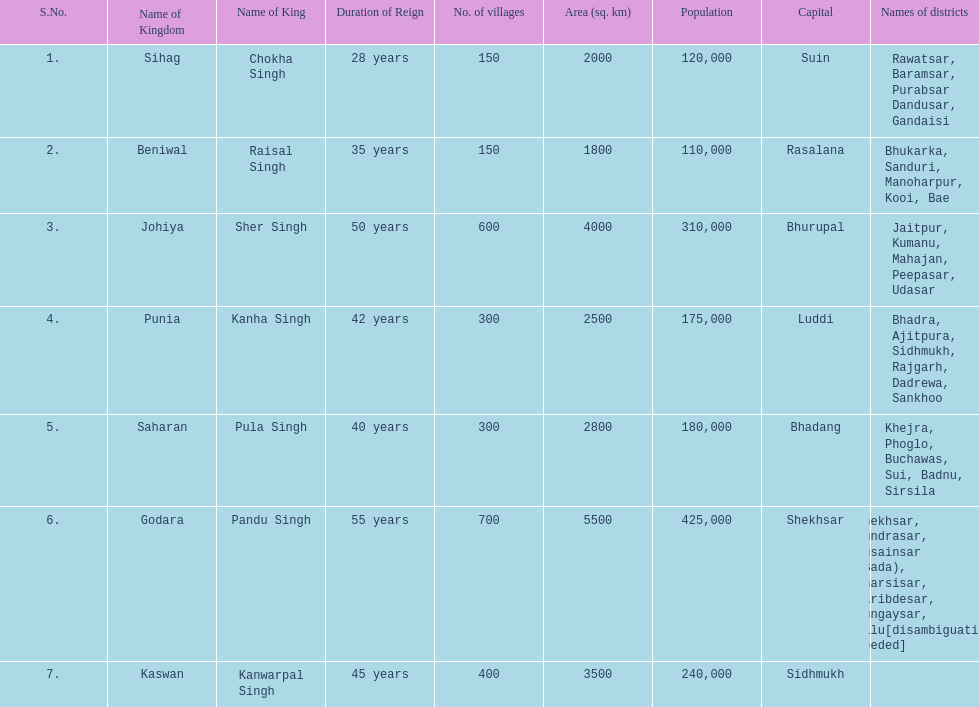What is the next realm mentioned after sihag? Beniwal. 